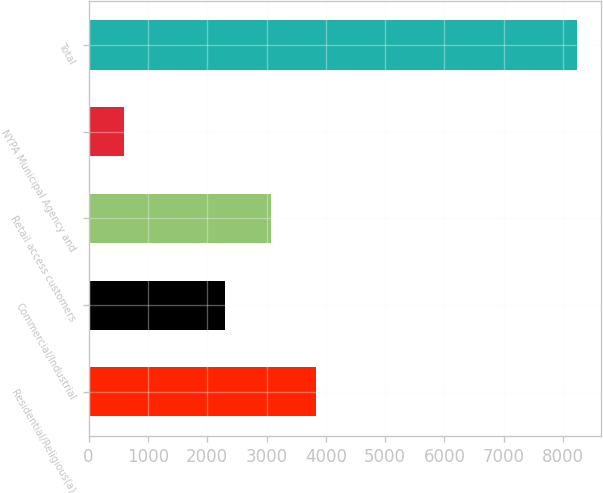Convert chart. <chart><loc_0><loc_0><loc_500><loc_500><bar_chart><fcel>Residential/Religious(a)<fcel>Commercial/Industrial<fcel>Retail access customers<fcel>NYPA Municipal Agency and<fcel>Total<nl><fcel>3831.2<fcel>2304<fcel>3067.6<fcel>592<fcel>8228<nl></chart> 